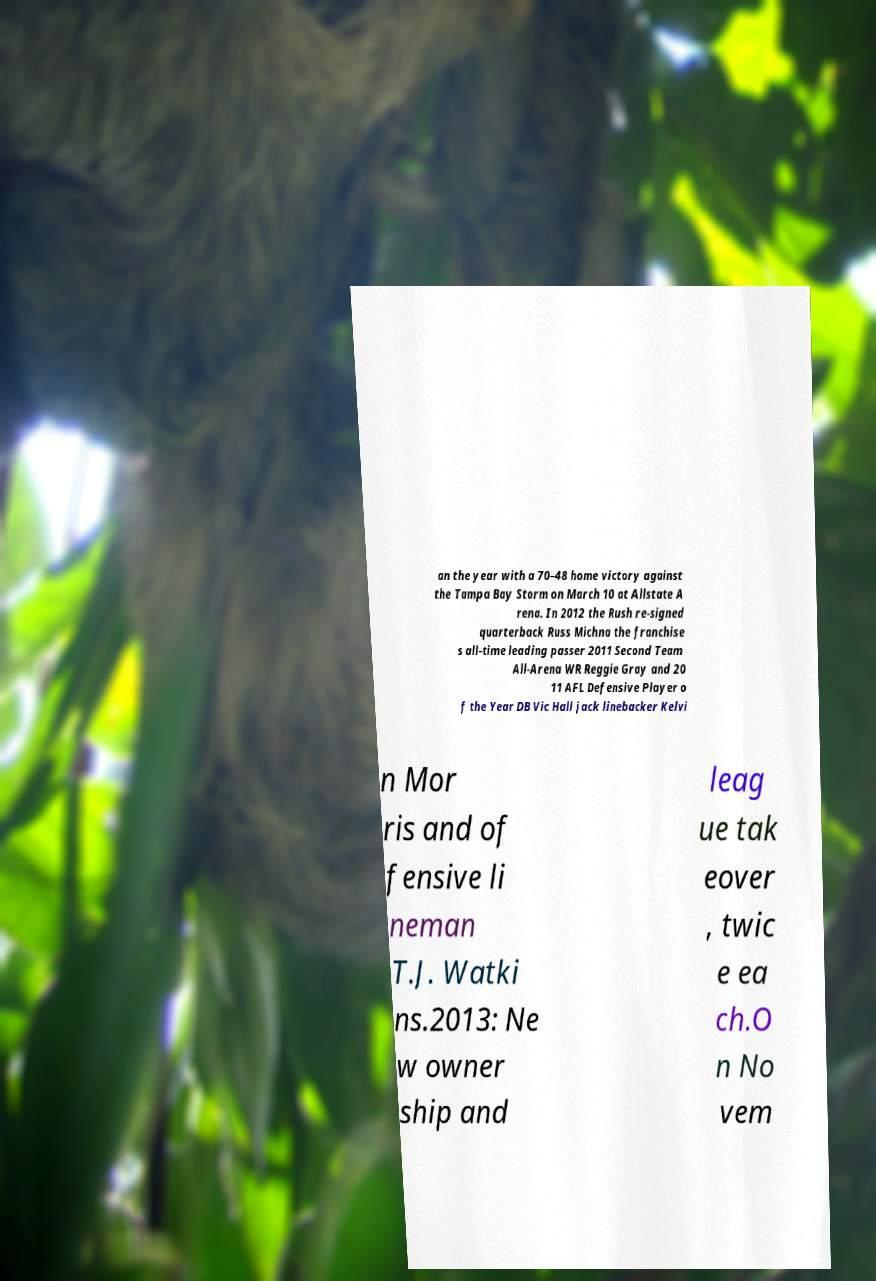Please read and relay the text visible in this image. What does it say? an the year with a 70–48 home victory against the Tampa Bay Storm on March 10 at Allstate A rena. In 2012 the Rush re-signed quarterback Russ Michna the franchise s all-time leading passer 2011 Second Team All-Arena WR Reggie Gray and 20 11 AFL Defensive Player o f the Year DB Vic Hall jack linebacker Kelvi n Mor ris and of fensive li neman T.J. Watki ns.2013: Ne w owner ship and leag ue tak eover , twic e ea ch.O n No vem 